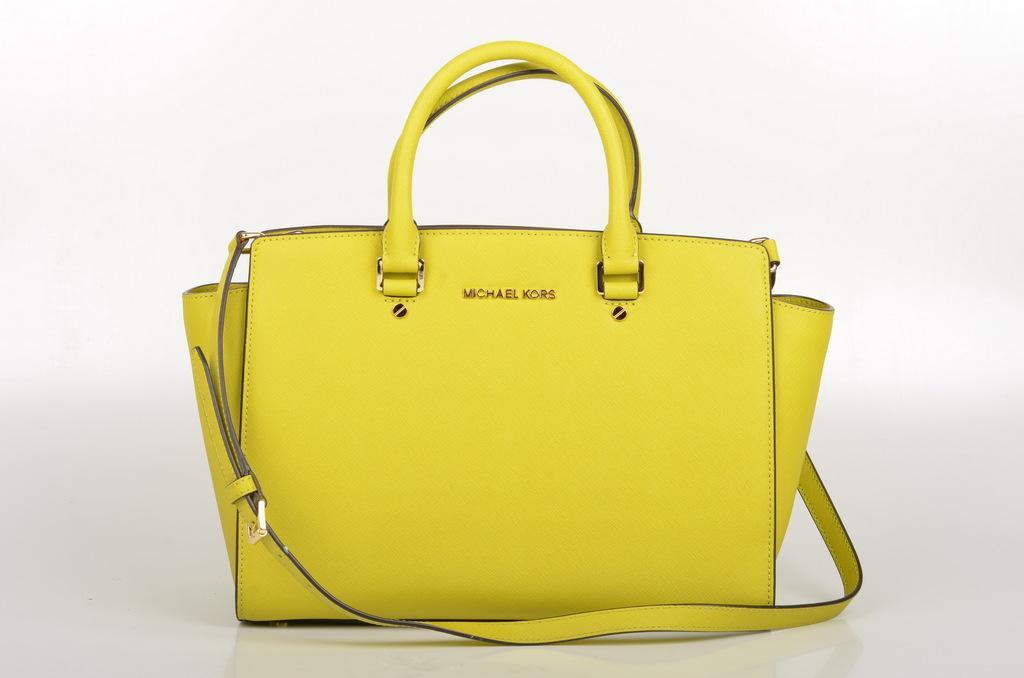Can you describe this image briefly? Yellow color bag with strap. 